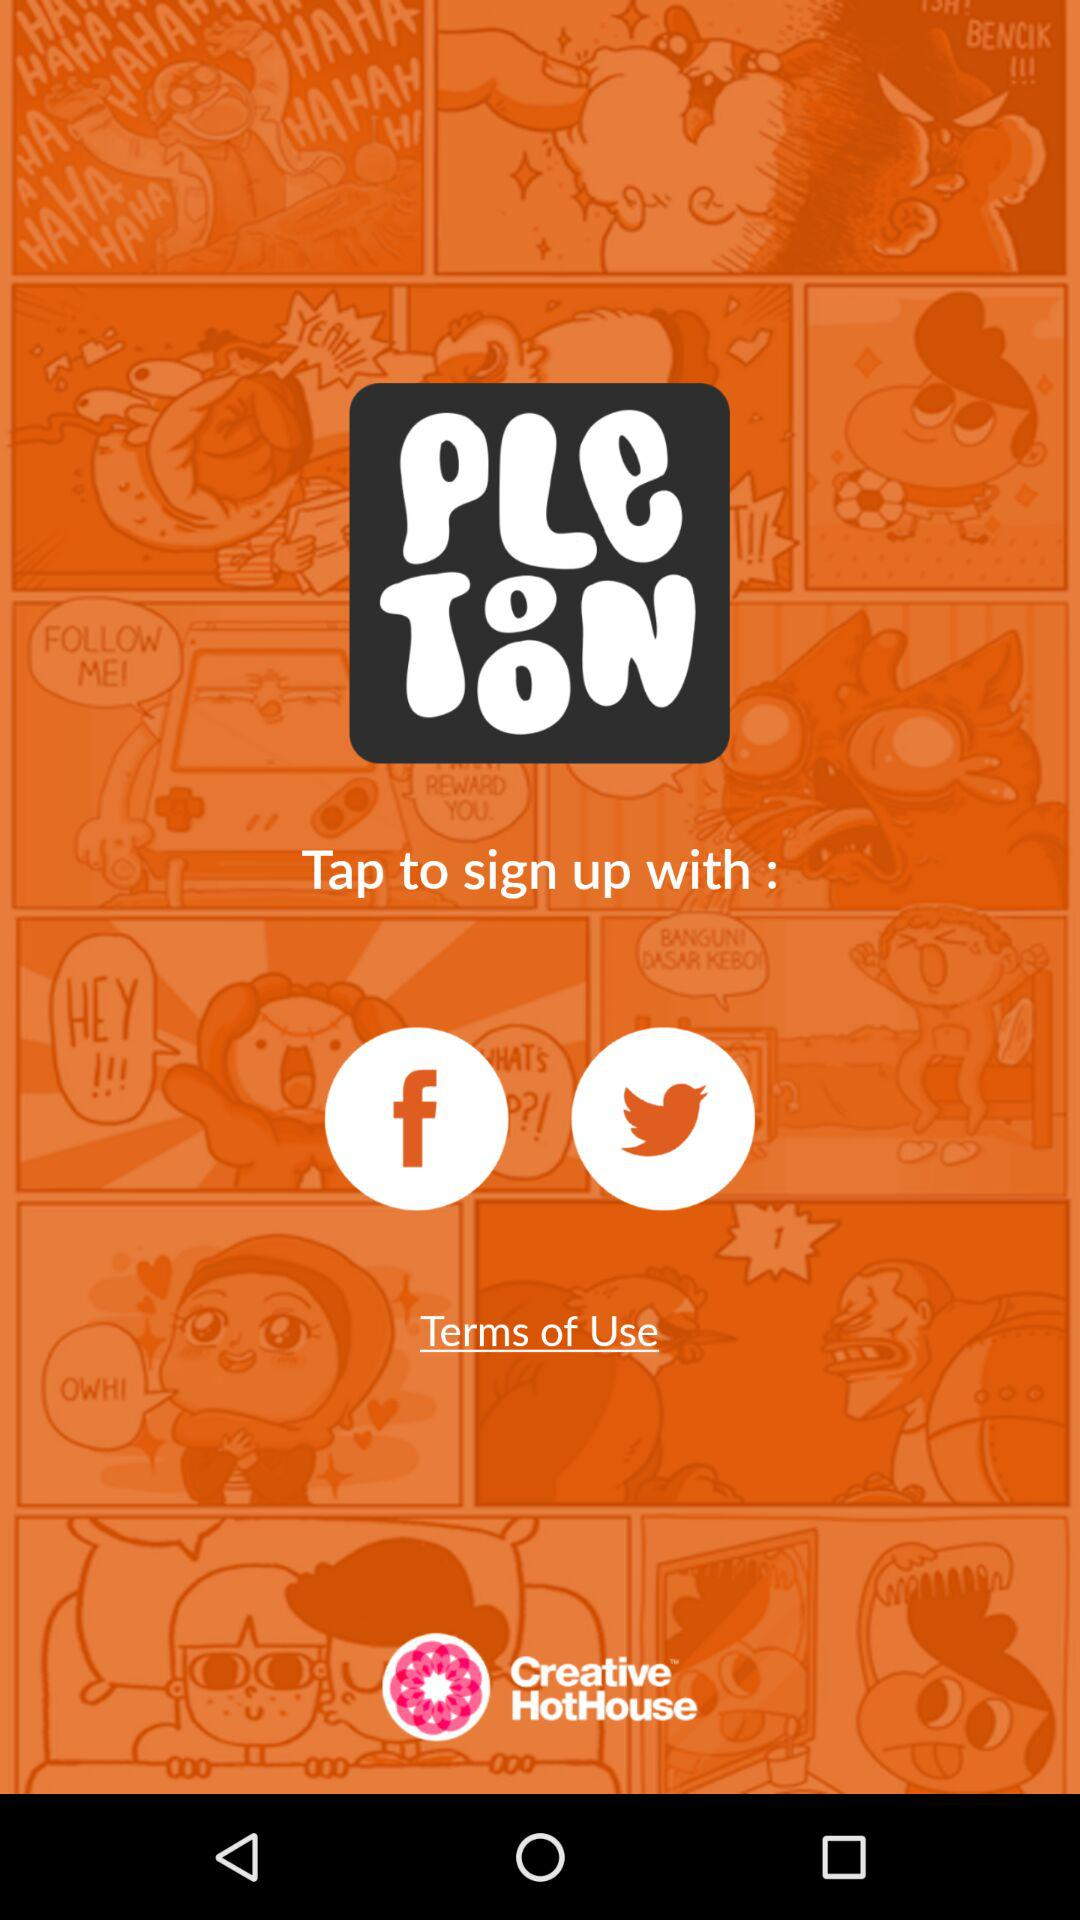What is the app name? The app name is "Pletoon". 